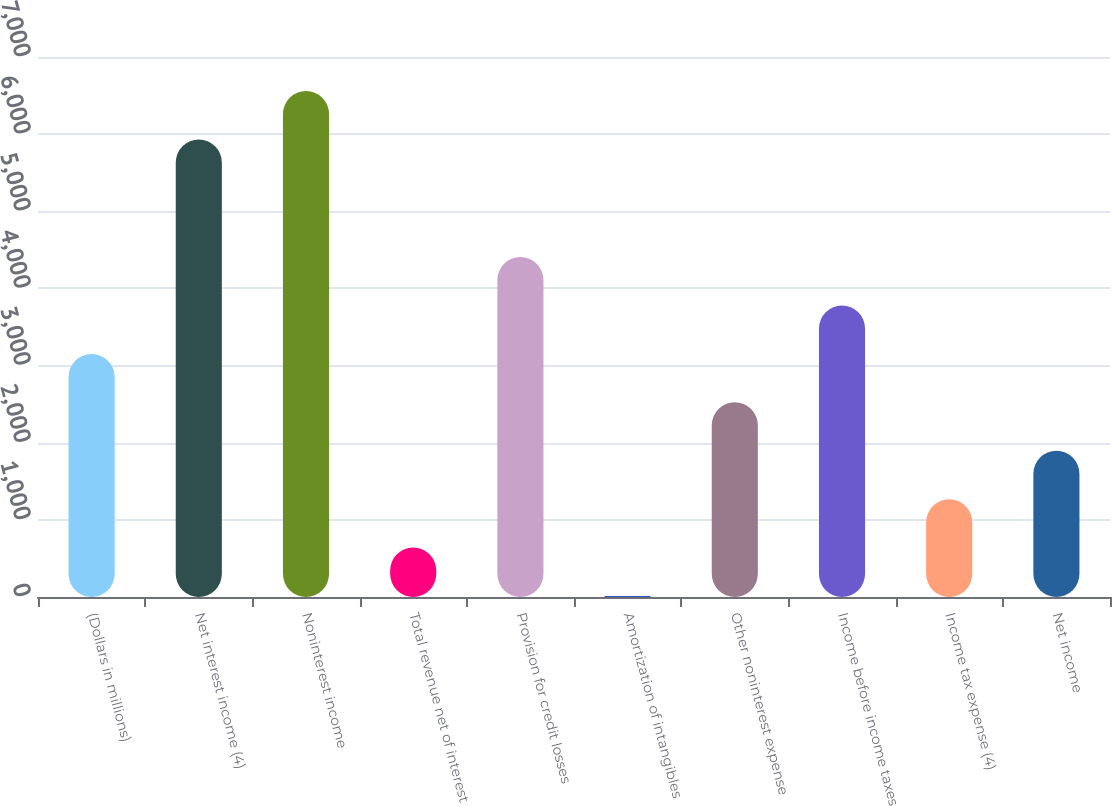<chart> <loc_0><loc_0><loc_500><loc_500><bar_chart><fcel>(Dollars in millions)<fcel>Net interest income (4)<fcel>Noninterest income<fcel>Total revenue net of interest<fcel>Provision for credit losses<fcel>Amortization of intangibles<fcel>Other noninterest expense<fcel>Income before income taxes<fcel>Income tax expense (4)<fcel>Net income<nl><fcel>3151.5<fcel>5930<fcel>6557.7<fcel>640.7<fcel>4406.9<fcel>13<fcel>2523.8<fcel>3779.2<fcel>1268.4<fcel>1896.1<nl></chart> 